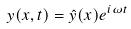Convert formula to latex. <formula><loc_0><loc_0><loc_500><loc_500>y ( x , t ) = \hat { y } ( x ) e ^ { i \omega t }</formula> 